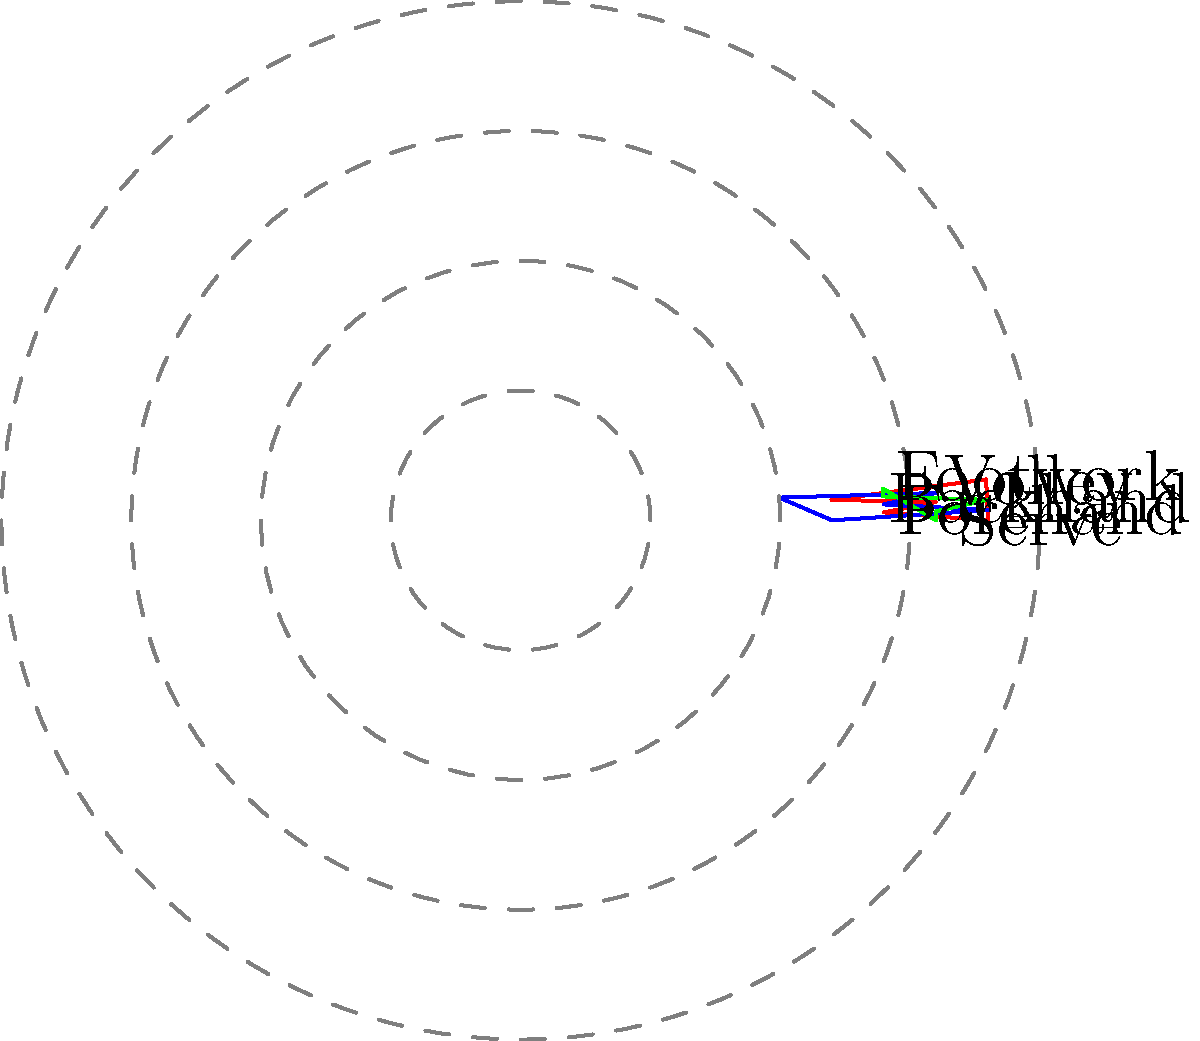Based on the radar charts representing the playing styles of three tennis players (A in red, B in blue, and C in green), which two players are most likely to be clustered together in a style-based analysis? To determine which two players are most likely to be clustered together, we need to compare their playing styles based on the radar charts. Let's analyze each player's strengths and weaknesses:

1. Player A (Red):
   - Strong serves and footwork
   - Balanced forehand and backhand
   - Relatively weaker volley

2. Player B (Blue):
   - Strong forehand
   - Good volley and backhand
   - Weaker serve and footwork

3. Player C (Green):
   - Strong backhand
   - Balanced across all skills
   - No significant weaknesses

To cluster players based on their playing styles, we look for similarities in their skill distributions. Players with more similar shapes in their radar charts are more likely to be clustered together.

Comparing the charts:
- Players A and B have quite different shapes, indicating different playing styles.
- Players A and C have some similarities in their overall balance, but A has more extreme strengths and weaknesses.
- Players B and C have the most similar shapes, with both showing strength in groundstrokes (forehand and backhand) and relatively balanced skills across the board.

Therefore, Players B and C are most likely to be clustered together in a style-based analysis due to their similar balanced approach and strength in groundstrokes.
Answer: Players B and C 